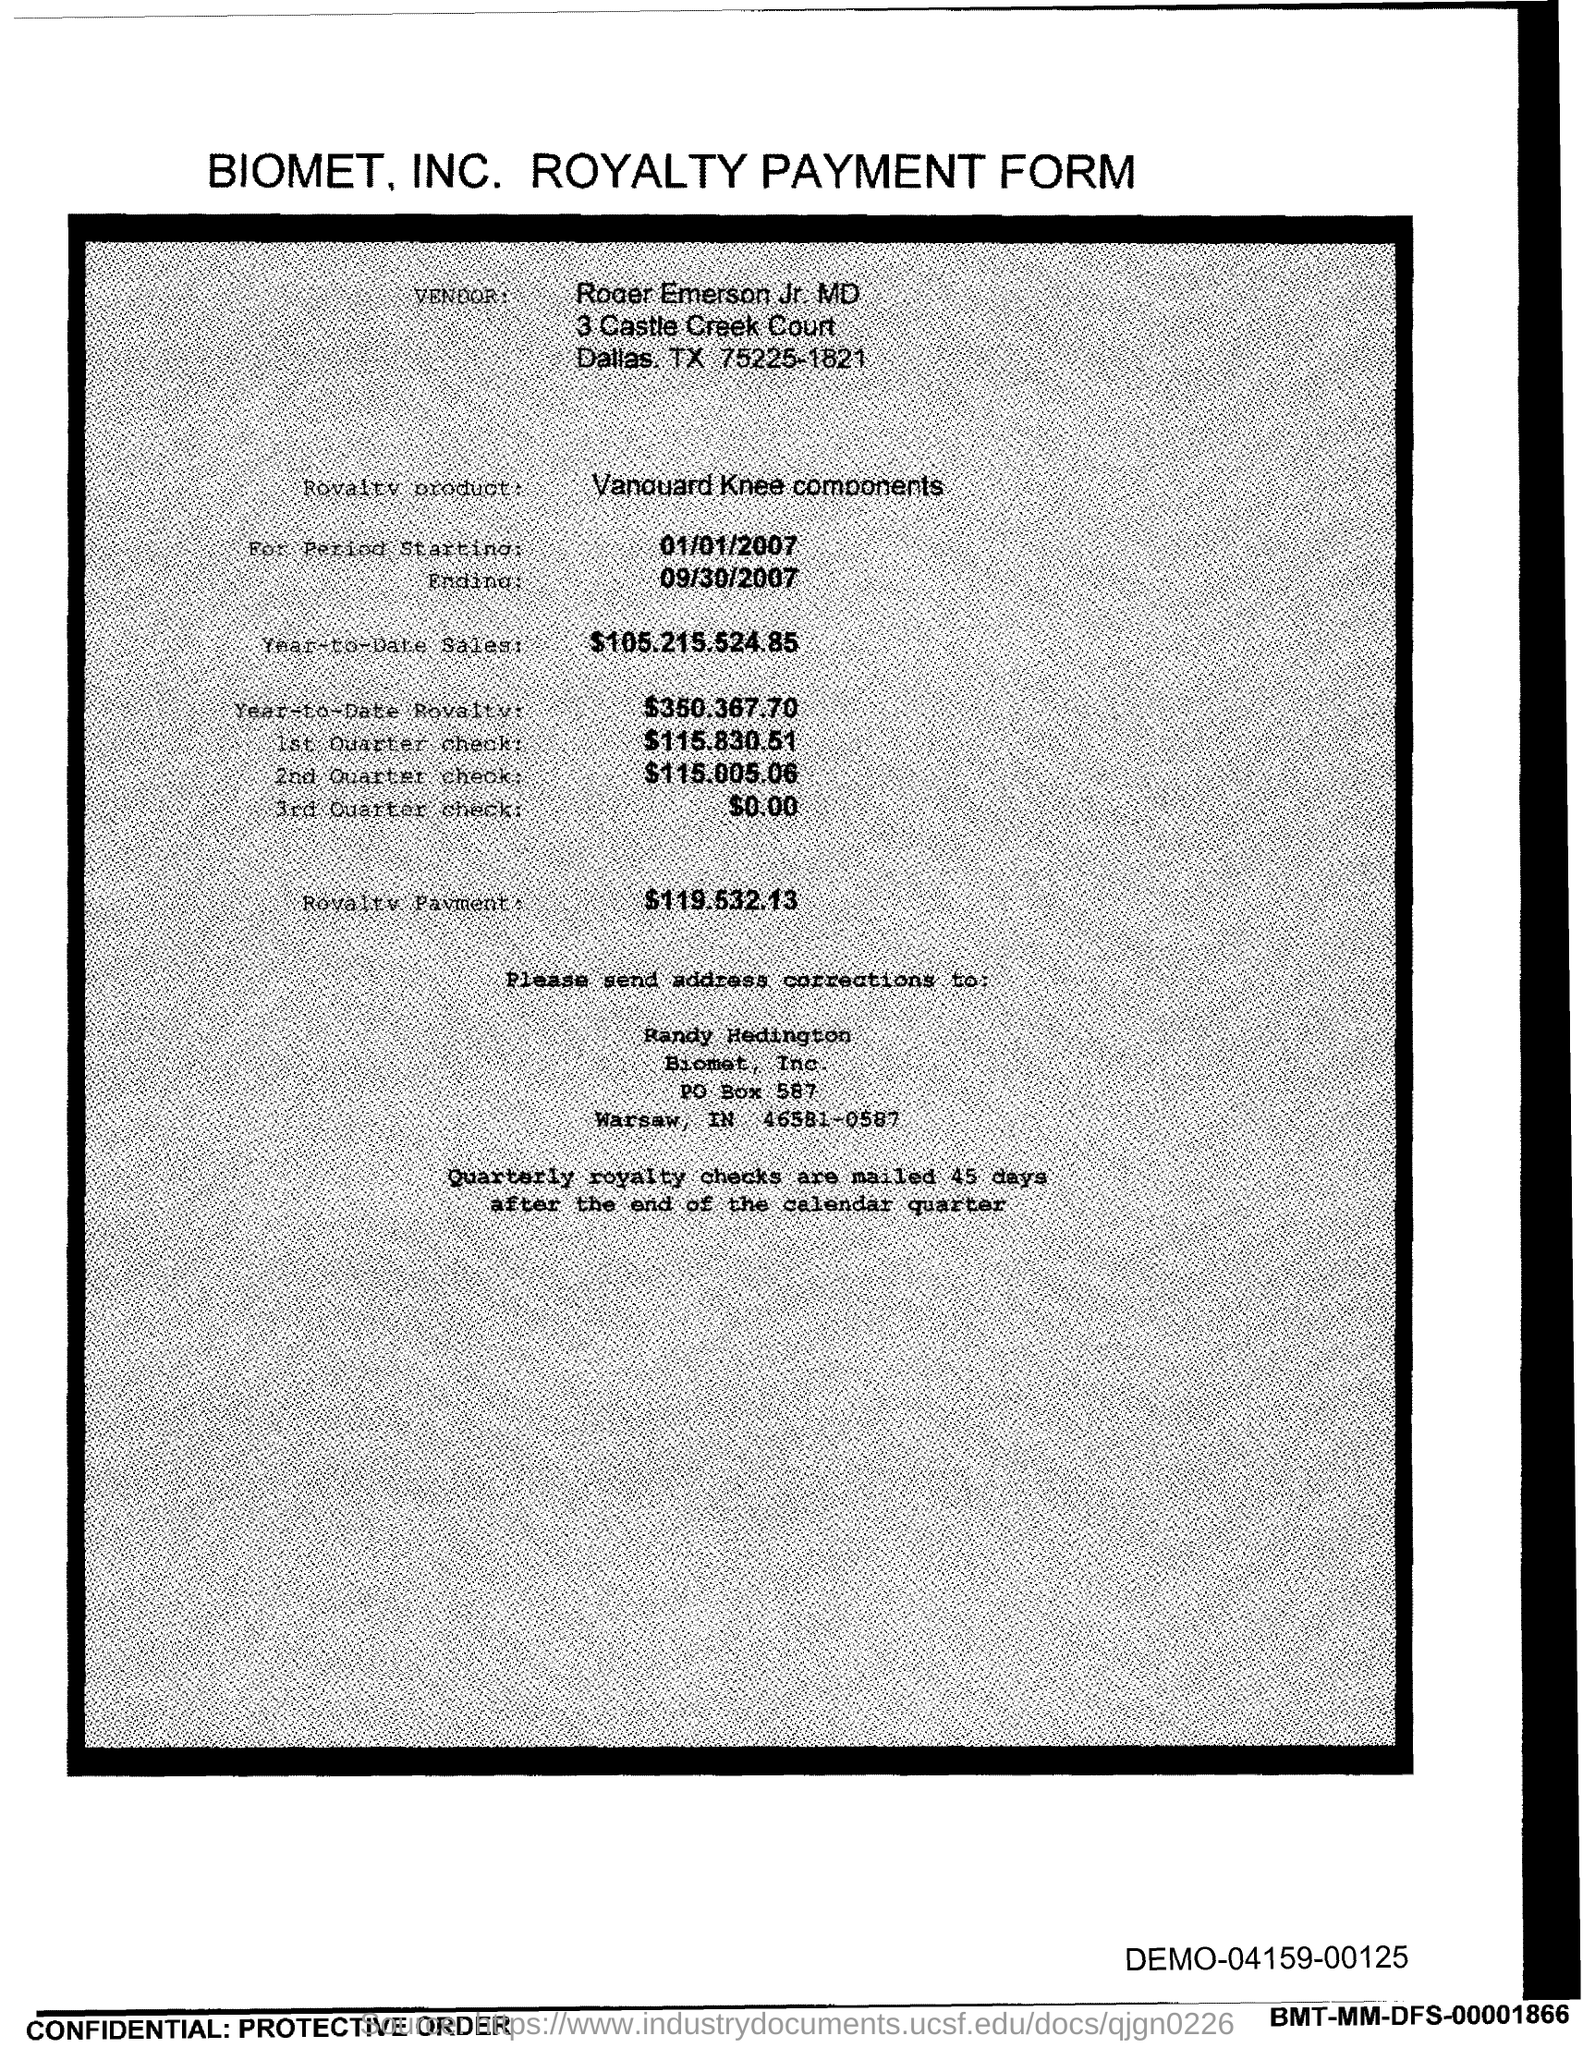What is the PO Box Number mentioned in the document?
Your response must be concise. 587. 